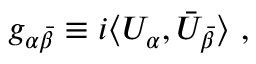<formula> <loc_0><loc_0><loc_500><loc_500>g _ { \alpha \bar { \beta } } \equiv i \langle U _ { \alpha } , \bar { U } _ { \bar { \beta } } \rangle \ ,</formula> 